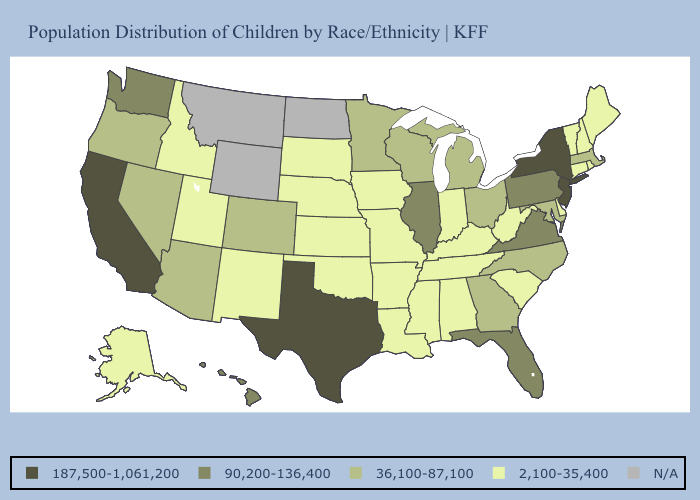What is the lowest value in states that border Utah?
Keep it brief. 2,100-35,400. Name the states that have a value in the range N/A?
Give a very brief answer. Montana, North Dakota, Wyoming. Name the states that have a value in the range 2,100-35,400?
Give a very brief answer. Alabama, Alaska, Arkansas, Connecticut, Delaware, Idaho, Indiana, Iowa, Kansas, Kentucky, Louisiana, Maine, Mississippi, Missouri, Nebraska, New Hampshire, New Mexico, Oklahoma, Rhode Island, South Carolina, South Dakota, Tennessee, Utah, Vermont, West Virginia. Name the states that have a value in the range 36,100-87,100?
Give a very brief answer. Arizona, Colorado, Georgia, Maryland, Massachusetts, Michigan, Minnesota, Nevada, North Carolina, Ohio, Oregon, Wisconsin. What is the value of Connecticut?
Be succinct. 2,100-35,400. Name the states that have a value in the range N/A?
Quick response, please. Montana, North Dakota, Wyoming. Name the states that have a value in the range 36,100-87,100?
Be succinct. Arizona, Colorado, Georgia, Maryland, Massachusetts, Michigan, Minnesota, Nevada, North Carolina, Ohio, Oregon, Wisconsin. Name the states that have a value in the range 2,100-35,400?
Answer briefly. Alabama, Alaska, Arkansas, Connecticut, Delaware, Idaho, Indiana, Iowa, Kansas, Kentucky, Louisiana, Maine, Mississippi, Missouri, Nebraska, New Hampshire, New Mexico, Oklahoma, Rhode Island, South Carolina, South Dakota, Tennessee, Utah, Vermont, West Virginia. What is the value of Wisconsin?
Write a very short answer. 36,100-87,100. Which states have the lowest value in the MidWest?
Quick response, please. Indiana, Iowa, Kansas, Missouri, Nebraska, South Dakota. Name the states that have a value in the range N/A?
Keep it brief. Montana, North Dakota, Wyoming. What is the value of Missouri?
Be succinct. 2,100-35,400. Name the states that have a value in the range 2,100-35,400?
Short answer required. Alabama, Alaska, Arkansas, Connecticut, Delaware, Idaho, Indiana, Iowa, Kansas, Kentucky, Louisiana, Maine, Mississippi, Missouri, Nebraska, New Hampshire, New Mexico, Oklahoma, Rhode Island, South Carolina, South Dakota, Tennessee, Utah, Vermont, West Virginia. Name the states that have a value in the range 90,200-136,400?
Answer briefly. Florida, Hawaii, Illinois, Pennsylvania, Virginia, Washington. 